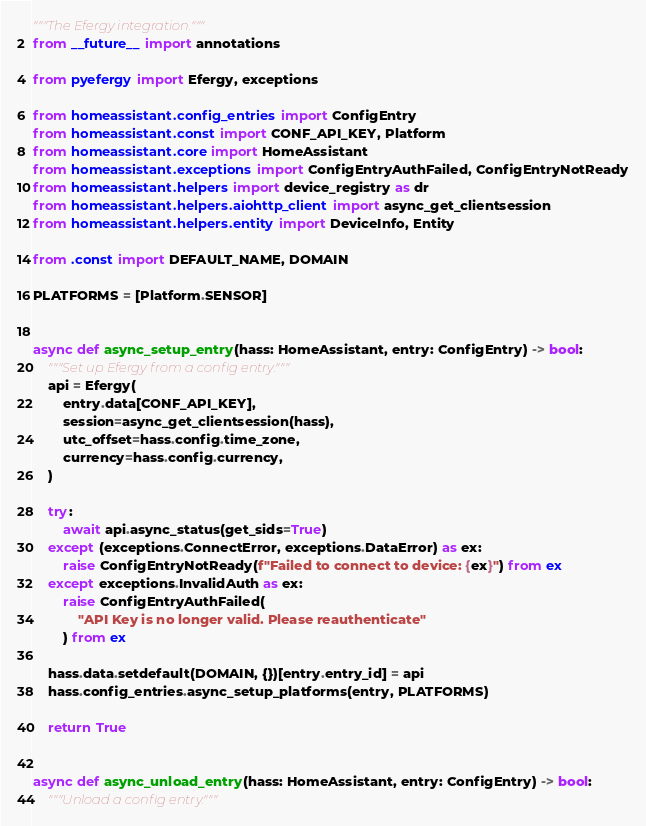<code> <loc_0><loc_0><loc_500><loc_500><_Python_>"""The Efergy integration."""
from __future__ import annotations

from pyefergy import Efergy, exceptions

from homeassistant.config_entries import ConfigEntry
from homeassistant.const import CONF_API_KEY, Platform
from homeassistant.core import HomeAssistant
from homeassistant.exceptions import ConfigEntryAuthFailed, ConfigEntryNotReady
from homeassistant.helpers import device_registry as dr
from homeassistant.helpers.aiohttp_client import async_get_clientsession
from homeassistant.helpers.entity import DeviceInfo, Entity

from .const import DEFAULT_NAME, DOMAIN

PLATFORMS = [Platform.SENSOR]


async def async_setup_entry(hass: HomeAssistant, entry: ConfigEntry) -> bool:
    """Set up Efergy from a config entry."""
    api = Efergy(
        entry.data[CONF_API_KEY],
        session=async_get_clientsession(hass),
        utc_offset=hass.config.time_zone,
        currency=hass.config.currency,
    )

    try:
        await api.async_status(get_sids=True)
    except (exceptions.ConnectError, exceptions.DataError) as ex:
        raise ConfigEntryNotReady(f"Failed to connect to device: {ex}") from ex
    except exceptions.InvalidAuth as ex:
        raise ConfigEntryAuthFailed(
            "API Key is no longer valid. Please reauthenticate"
        ) from ex

    hass.data.setdefault(DOMAIN, {})[entry.entry_id] = api
    hass.config_entries.async_setup_platforms(entry, PLATFORMS)

    return True


async def async_unload_entry(hass: HomeAssistant, entry: ConfigEntry) -> bool:
    """Unload a config entry."""</code> 